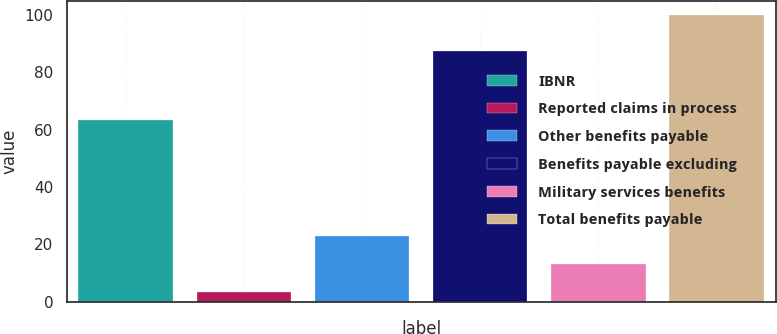Convert chart to OTSL. <chart><loc_0><loc_0><loc_500><loc_500><bar_chart><fcel>IBNR<fcel>Reported claims in process<fcel>Other benefits payable<fcel>Benefits payable excluding<fcel>Military services benefits<fcel>Total benefits payable<nl><fcel>63.5<fcel>3.4<fcel>22.72<fcel>87.3<fcel>13.06<fcel>100<nl></chart> 